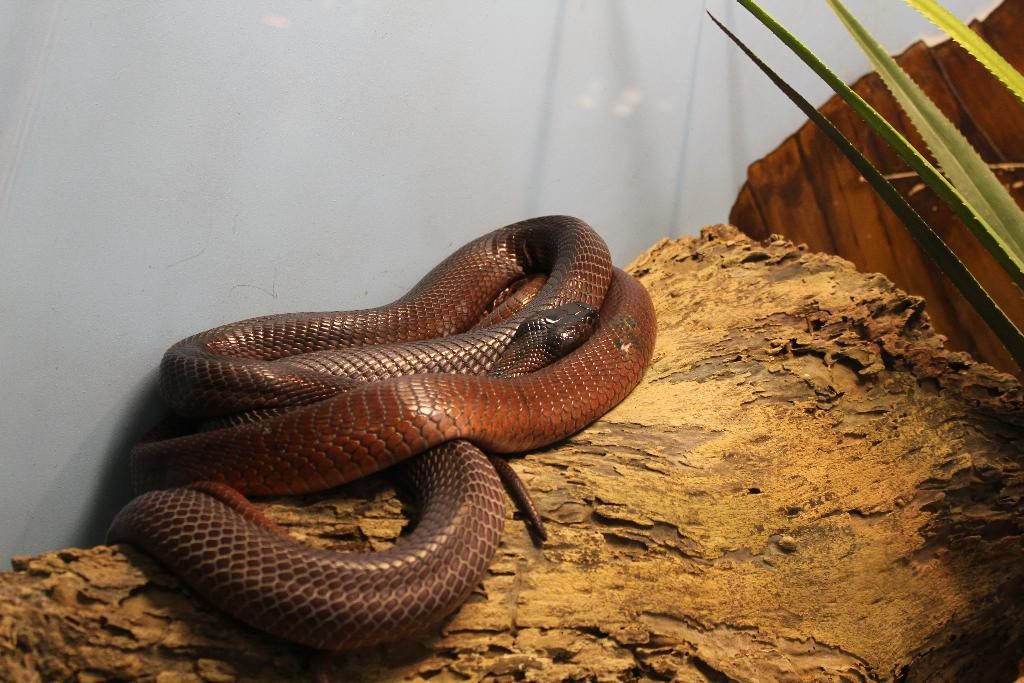What type of animal is in the image? There is a snake in the image. What color is the snake? The snake is brown in color. What other living organism is in the image? There is a plant in the image. What type of material is the wooden object made of? The wooden object is made of wood. What can be seen in the background of the image? There is a white wall in the background of the image. Where is the cobweb located in the image? There is no cobweb present in the image. What type of seat can be seen in the image? There is no seat present in the image. 